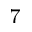<formula> <loc_0><loc_0><loc_500><loc_500>^ { 7 }</formula> 